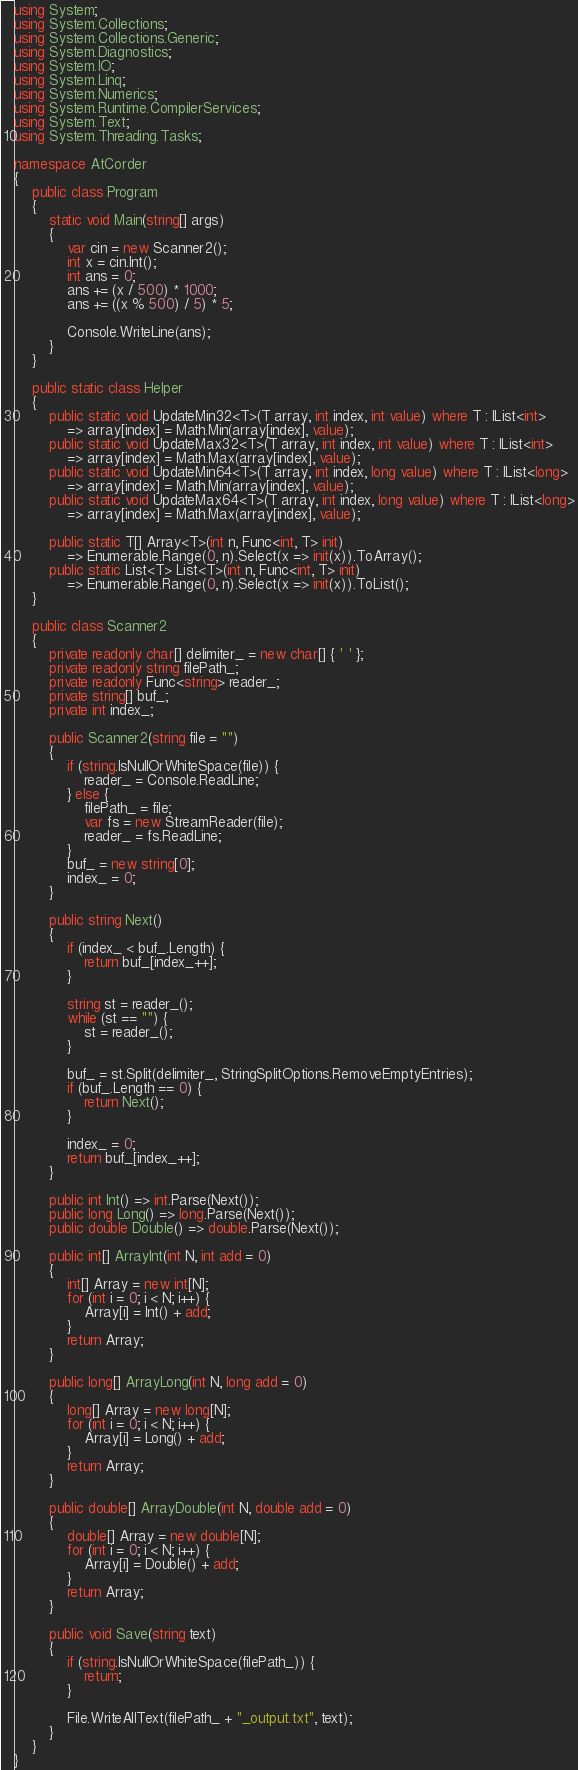<code> <loc_0><loc_0><loc_500><loc_500><_C#_>using System;
using System.Collections;
using System.Collections.Generic;
using System.Diagnostics;
using System.IO;
using System.Linq;
using System.Numerics;
using System.Runtime.CompilerServices;
using System.Text;
using System.Threading.Tasks;

namespace AtCorder
{
	public class Program
	{
		static void Main(string[] args)
		{
			var cin = new Scanner2();
			int x = cin.Int();
			int ans = 0;
			ans += (x / 500) * 1000;
			ans += ((x % 500) / 5) * 5;

			Console.WriteLine(ans);
		}
	}

	public static class Helper
	{
		public static void UpdateMin32<T>(T array, int index, int value) where T : IList<int>
			=> array[index] = Math.Min(array[index], value);
		public static void UpdateMax32<T>(T array, int index, int value) where T : IList<int>
			=> array[index] = Math.Max(array[index], value);
		public static void UpdateMin64<T>(T array, int index, long value) where T : IList<long>
			=> array[index] = Math.Min(array[index], value);
		public static void UpdateMax64<T>(T array, int index, long value) where T : IList<long>
			=> array[index] = Math.Max(array[index], value);

		public static T[] Array<T>(int n, Func<int, T> init)
			=> Enumerable.Range(0, n).Select(x => init(x)).ToArray();
		public static List<T> List<T>(int n, Func<int, T> init)
			=> Enumerable.Range(0, n).Select(x => init(x)).ToList();
	}

	public class Scanner2
	{
		private readonly char[] delimiter_ = new char[] { ' ' };
		private readonly string filePath_;
		private readonly Func<string> reader_;
		private string[] buf_;
		private int index_;

		public Scanner2(string file = "")
		{
			if (string.IsNullOrWhiteSpace(file)) {
				reader_ = Console.ReadLine;
			} else {
				filePath_ = file;
				var fs = new StreamReader(file);
				reader_ = fs.ReadLine;
			}
			buf_ = new string[0];
			index_ = 0;
		}

		public string Next()
		{
			if (index_ < buf_.Length) {
				return buf_[index_++];
			}

			string st = reader_();
			while (st == "") {
				st = reader_();
			}

			buf_ = st.Split(delimiter_, StringSplitOptions.RemoveEmptyEntries);
			if (buf_.Length == 0) {
				return Next();
			}

			index_ = 0;
			return buf_[index_++];
		}

		public int Int() => int.Parse(Next());
		public long Long() => long.Parse(Next());
		public double Double() => double.Parse(Next());

		public int[] ArrayInt(int N, int add = 0)
		{
			int[] Array = new int[N];
			for (int i = 0; i < N; i++) {
				Array[i] = Int() + add;
			}
			return Array;
		}

		public long[] ArrayLong(int N, long add = 0)
		{
			long[] Array = new long[N];
			for (int i = 0; i < N; i++) {
				Array[i] = Long() + add;
			}
			return Array;
		}

		public double[] ArrayDouble(int N, double add = 0)
		{
			double[] Array = new double[N];
			for (int i = 0; i < N; i++) {
				Array[i] = Double() + add;
			}
			return Array;
		}

		public void Save(string text)
		{
			if (string.IsNullOrWhiteSpace(filePath_)) {
				return;
			}

			File.WriteAllText(filePath_ + "_output.txt", text);
		}
	}
}</code> 